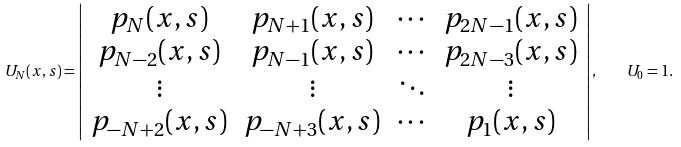Convert formula to latex. <formula><loc_0><loc_0><loc_500><loc_500>U _ { N } ( x , s ) = \left | \begin{array} { c c c c } p _ { N } ( x , s ) & p _ { N + 1 } ( x , s ) & \cdots & p _ { 2 N - 1 } ( x , s ) \\ p _ { N - 2 } ( x , s ) & p _ { N - 1 } ( x , s ) & \cdots & p _ { 2 N - 3 } ( x , s ) \\ \vdots & \vdots & \ddots & \vdots \\ p _ { - N + 2 } ( x , s ) & p _ { - N + 3 } ( x , s ) & \cdots & p _ { 1 } ( x , s ) \\ \end{array} \right | , \quad U _ { 0 } = 1 .</formula> 